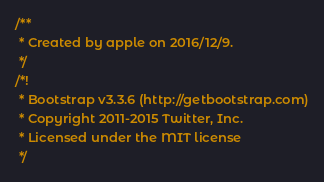Convert code to text. <code><loc_0><loc_0><loc_500><loc_500><_JavaScript_>/**
 * Created by apple on 2016/12/9.
 */
/*!
 * Bootstrap v3.3.6 (http://getbootstrap.com)
 * Copyright 2011-2015 Twitter, Inc.
 * Licensed under the MIT license
 */</code> 